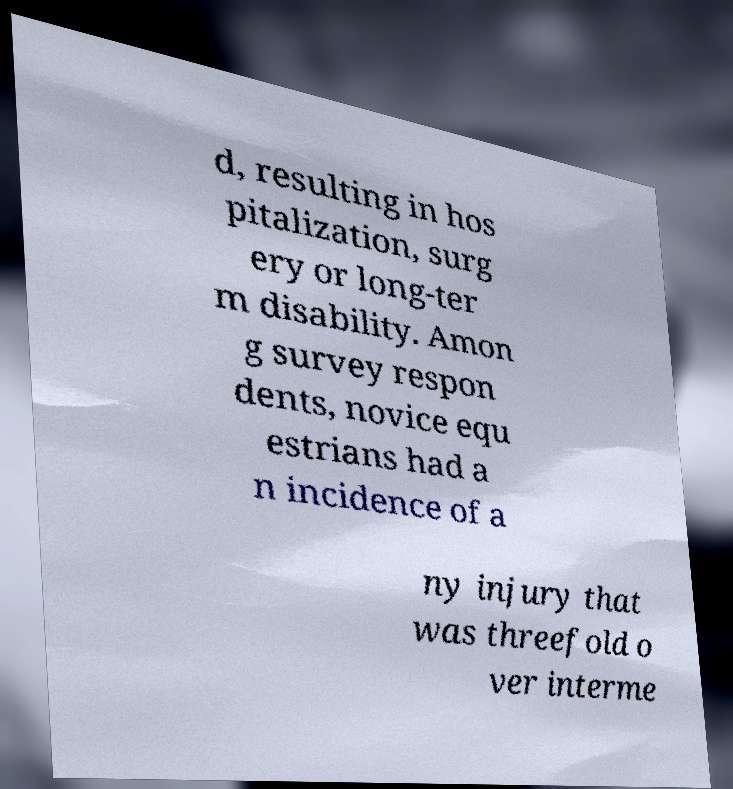Can you read and provide the text displayed in the image?This photo seems to have some interesting text. Can you extract and type it out for me? d, resulting in hos pitalization, surg ery or long-ter m disability. Amon g survey respon dents, novice equ estrians had a n incidence of a ny injury that was threefold o ver interme 